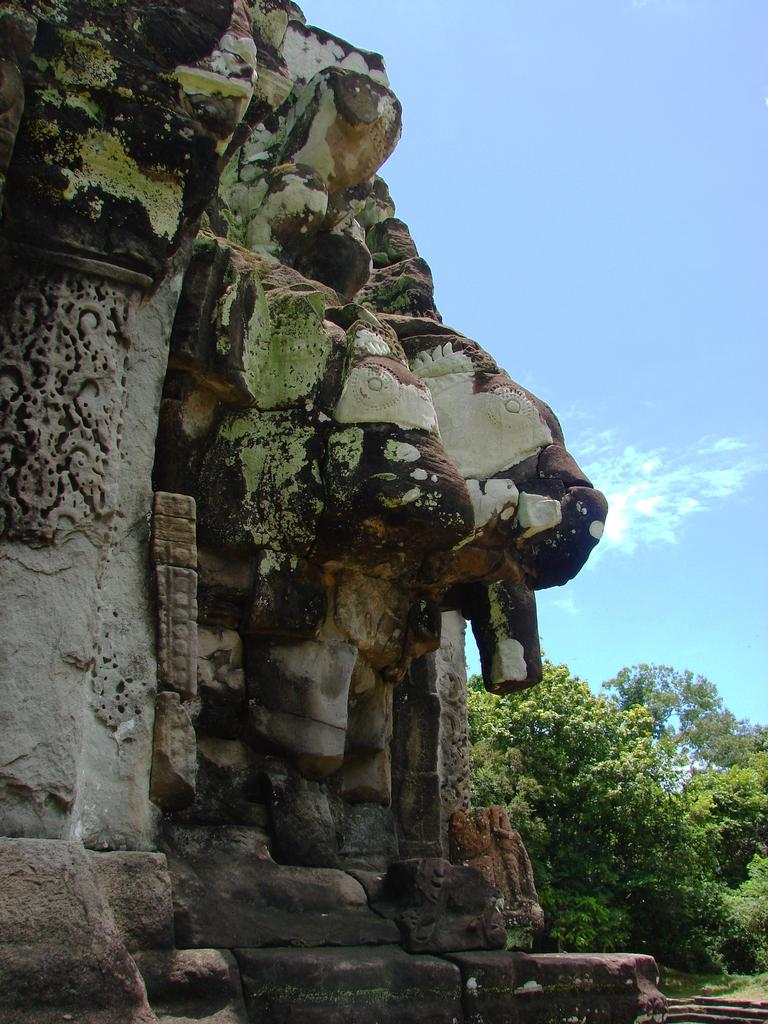What can be seen on the wall on the left side of the image? There are sculptures on a wall on the left side of the image. What type of natural elements are visible in the background of the image? There are trees in the background of the image. What is the color of the sky in the image? The sky is blue in the image. What else can be seen in the sky besides the blue color? There are clouds in the sky. What type of base can be seen supporting the trees in the image? There is no base supporting the trees in the image; they are standing on the ground. How does the face of the sculpture on the wall look like in the image? There is no face visible on the sculptures in the image; they are abstract shapes. 